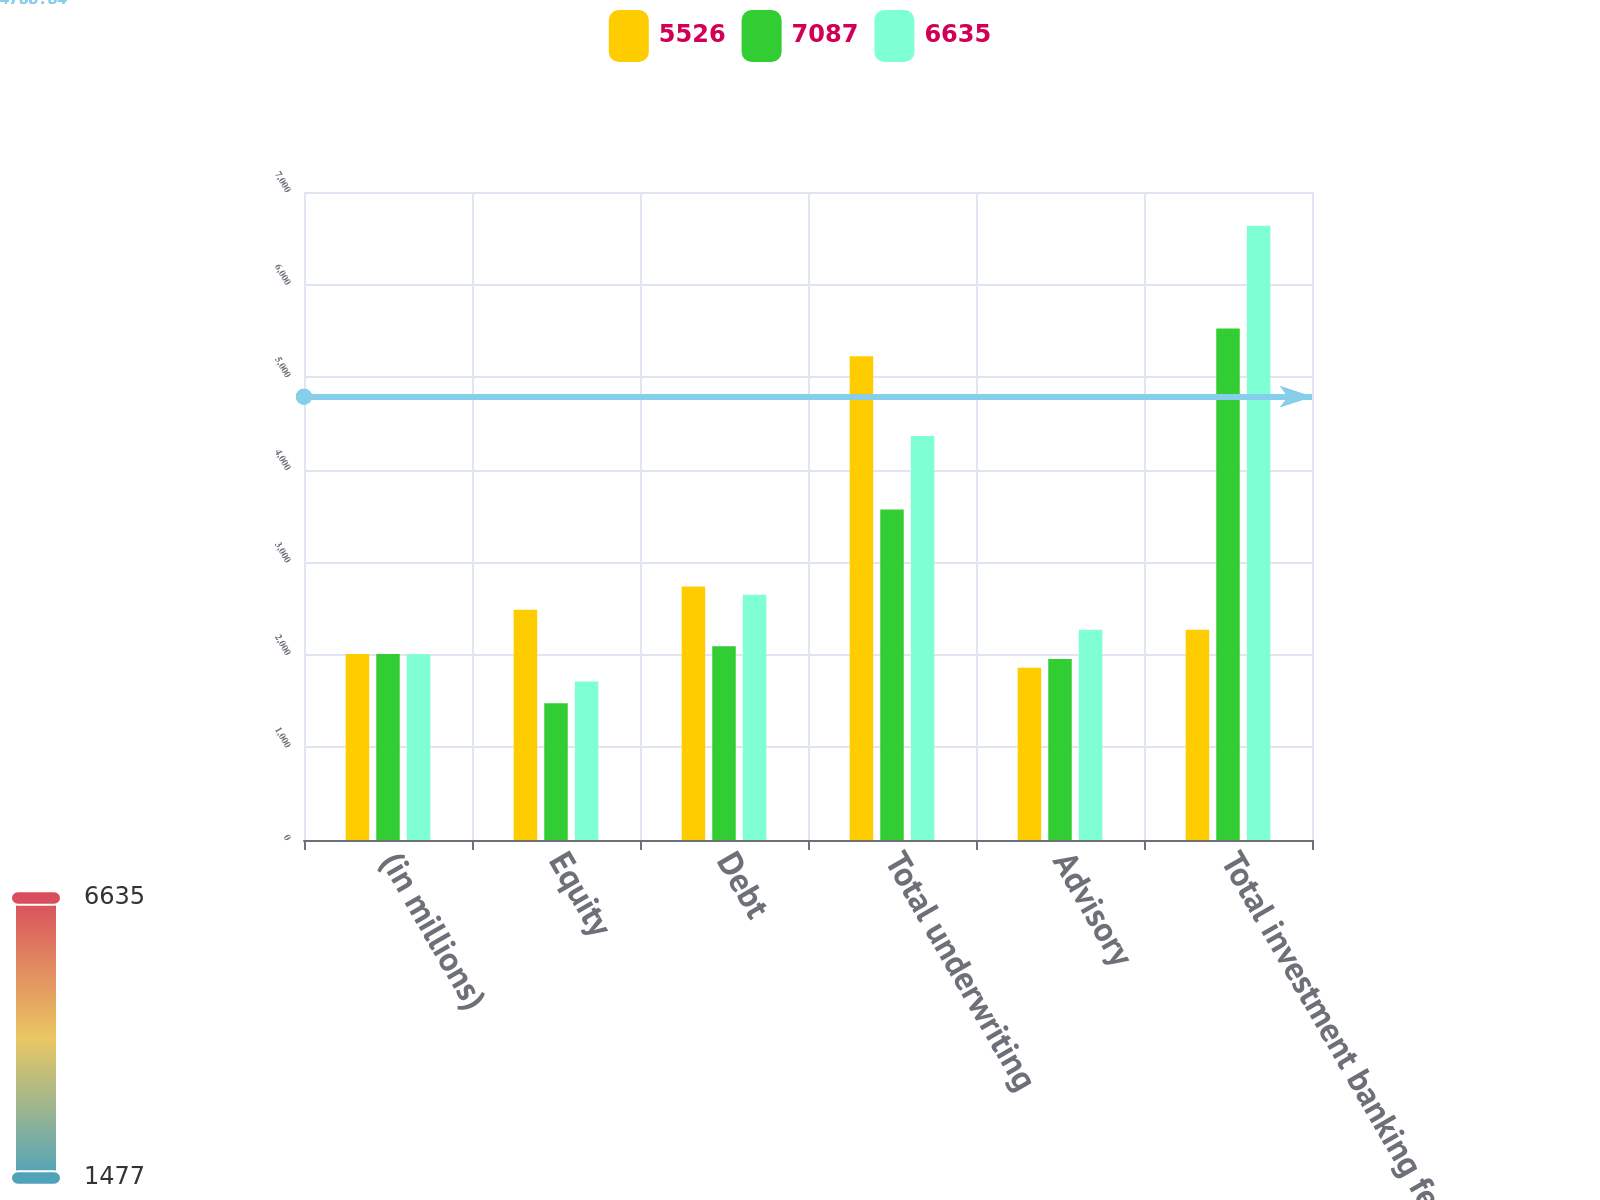Convert chart to OTSL. <chart><loc_0><loc_0><loc_500><loc_500><stacked_bar_chart><ecel><fcel>(in millions)<fcel>Equity<fcel>Debt<fcel>Total underwriting<fcel>Advisory<fcel>Total investment banking fees<nl><fcel>5526<fcel>2009<fcel>2487<fcel>2739<fcel>5226<fcel>1861<fcel>2272<nl><fcel>7087<fcel>2008<fcel>1477<fcel>2094<fcel>3571<fcel>1955<fcel>5526<nl><fcel>6635<fcel>2007<fcel>1713<fcel>2650<fcel>4363<fcel>2272<fcel>6635<nl></chart> 